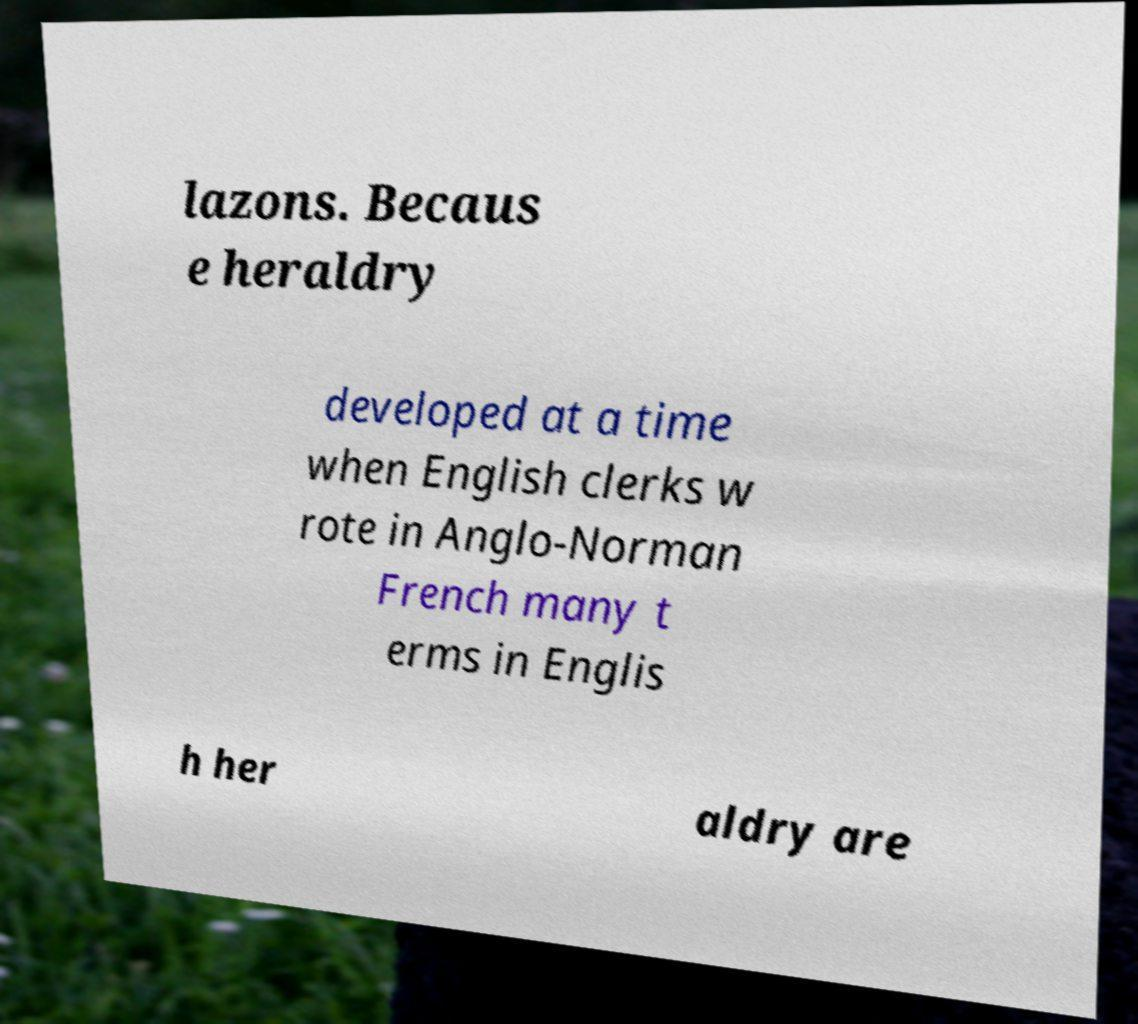Can you read and provide the text displayed in the image?This photo seems to have some interesting text. Can you extract and type it out for me? lazons. Becaus e heraldry developed at a time when English clerks w rote in Anglo-Norman French many t erms in Englis h her aldry are 